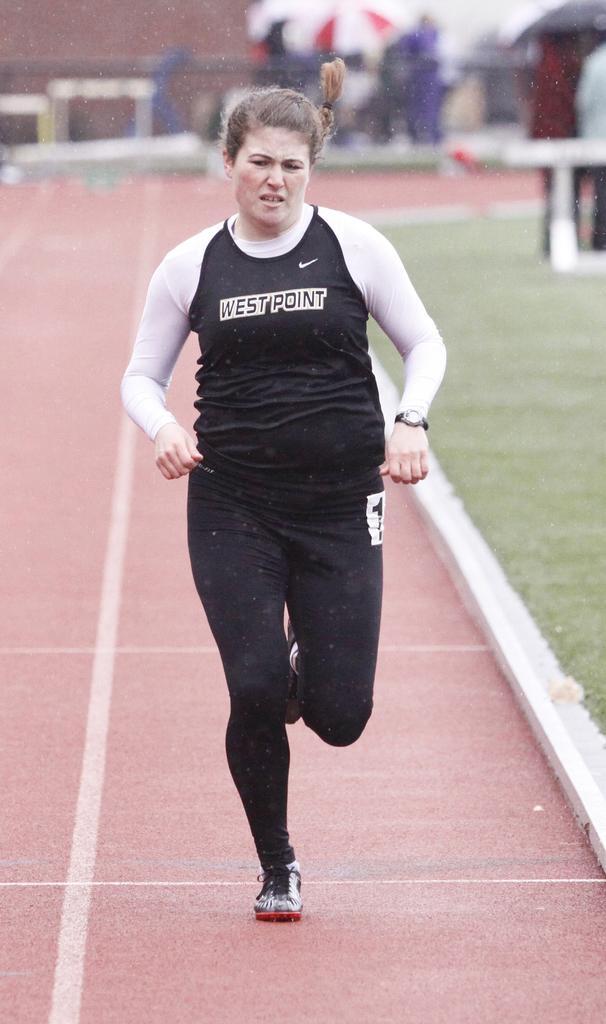Please provide a concise description of this image. In this image we can see one woman running, two people are standing on the ground, some poles, some flags, one big wall, some objects on the surface and some green grass on the ground. 